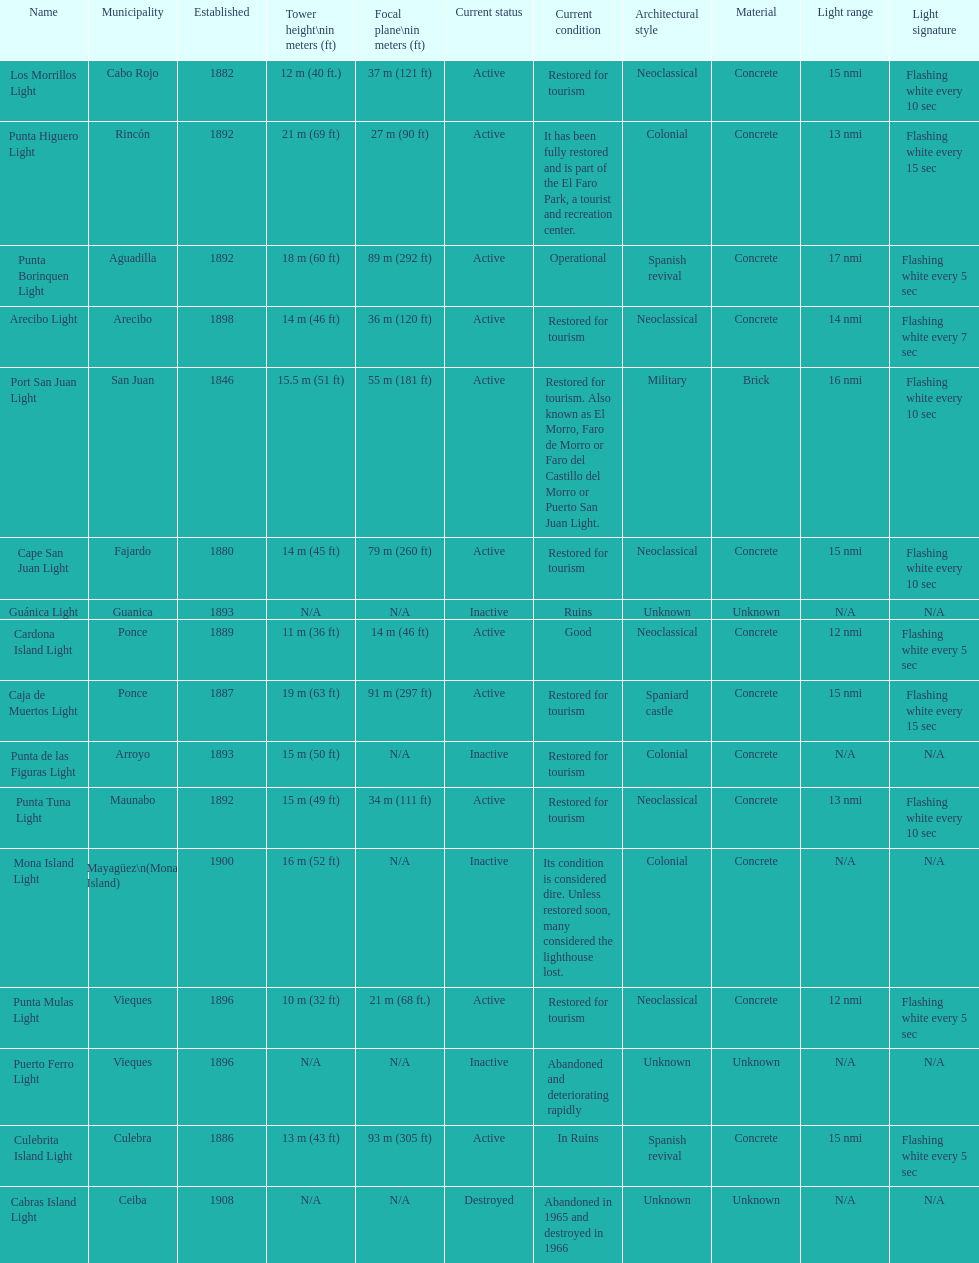Help me parse the entirety of this table. {'header': ['Name', 'Municipality', 'Established', 'Tower height\\nin meters (ft)', 'Focal plane\\nin meters (ft)', 'Current status', 'Current condition', 'Architectural style', 'Material', 'Light range', 'Light signature'], 'rows': [['Los Morrillos Light', 'Cabo Rojo', '1882', '12\xa0m (40\xa0ft.)', '37\xa0m (121\xa0ft)', 'Active', 'Restored for tourism', 'Neoclassical', 'Concrete', '15 nmi', 'Flashing white every 10 sec'], ['Punta Higuero Light', 'Rincón', '1892', '21\xa0m (69\xa0ft)', '27\xa0m (90\xa0ft)', 'Active', 'It has been fully restored and is part of the El Faro Park, a tourist and recreation center.', 'Colonial', 'Concrete', '13 nmi', 'Flashing white every 15 sec'], ['Punta Borinquen Light', 'Aguadilla', '1892', '18\xa0m (60\xa0ft)', '89\xa0m (292\xa0ft)', 'Active', 'Operational', 'Spanish revival', 'Concrete', '17 nmi', 'Flashing white every 5 sec'], ['Arecibo Light', 'Arecibo', '1898', '14\xa0m (46\xa0ft)', '36\xa0m (120\xa0ft)', 'Active', 'Restored for tourism', 'Neoclassical', 'Concrete', '14 nmi', 'Flashing white every 7 sec'], ['Port San Juan Light', 'San Juan', '1846', '15.5\xa0m (51\xa0ft)', '55\xa0m (181\xa0ft)', 'Active', 'Restored for tourism. Also known as El Morro, Faro de Morro or Faro del Castillo del Morro or Puerto San Juan Light.', 'Military', 'Brick', '16 nmi', 'Flashing white every 10 sec'], ['Cape San Juan Light', 'Fajardo', '1880', '14\xa0m (45\xa0ft)', '79\xa0m (260\xa0ft)', 'Active', 'Restored for tourism', 'Neoclassical', 'Concrete', '15 nmi', 'Flashing white every 10 sec'], ['Guánica Light', 'Guanica', '1893', 'N/A', 'N/A', 'Inactive', 'Ruins', 'Unknown', 'Unknown', 'N/A', 'N/A'], ['Cardona Island Light', 'Ponce', '1889', '11\xa0m (36\xa0ft)', '14\xa0m (46\xa0ft)', 'Active', 'Good', 'Neoclassical', 'Concrete', '12 nmi', 'Flashing white every 5 sec'], ['Caja de Muertos Light', 'Ponce', '1887', '19\xa0m (63\xa0ft)', '91\xa0m (297\xa0ft)', 'Active', 'Restored for tourism', 'Spaniard castle', 'Concrete', '15 nmi', 'Flashing white every 15 sec'], ['Punta de las Figuras Light', 'Arroyo', '1893', '15\xa0m (50\xa0ft)', 'N/A', 'Inactive', 'Restored for tourism', 'Colonial', 'Concrete', 'N/A', 'N/A'], ['Punta Tuna Light', 'Maunabo', '1892', '15\xa0m (49\xa0ft)', '34\xa0m (111\xa0ft)', 'Active', 'Restored for tourism', 'Neoclassical', 'Concrete', '13 nmi', 'Flashing white every 10 sec'], ['Mona Island Light', 'Mayagüez\\n(Mona Island)', '1900', '16\xa0m (52\xa0ft)', 'N/A', 'Inactive', 'Its condition is considered dire. Unless restored soon, many considered the lighthouse lost.', 'Colonial', 'Concrete', 'N/A', 'N/A'], ['Punta Mulas Light', 'Vieques', '1896', '10\xa0m (32\xa0ft)', '21\xa0m (68\xa0ft.)', 'Active', 'Restored for tourism', 'Neoclassical', 'Concrete', '12 nmi', 'Flashing white every 5 sec'], ['Puerto Ferro Light', 'Vieques', '1896', 'N/A', 'N/A', 'Inactive', 'Abandoned and deteriorating rapidly', 'Unknown', 'Unknown', 'N/A', 'N/A'], ['Culebrita Island Light', 'Culebra', '1886', '13\xa0m (43\xa0ft)', '93\xa0m (305\xa0ft)', 'Active', 'In Ruins', 'Spanish revival', 'Concrete', '15 nmi', 'Flashing white every 5 sec'], ['Cabras Island Light', 'Ceiba', '1908', 'N/A', 'N/A', 'Destroyed', 'Abandoned in 1965 and destroyed in 1966', 'Unknown', 'Unknown', 'N/A', 'N/A']]} Number of lighthouses that begin with the letter p 7. 